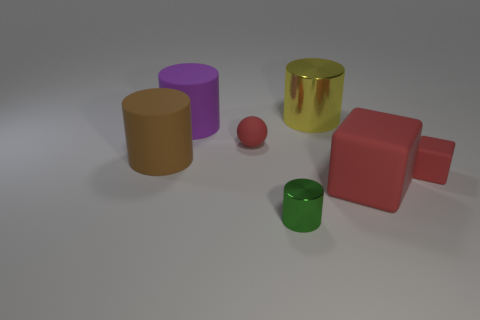Subtract all purple cylinders. How many cylinders are left? 3 Subtract all cylinders. How many objects are left? 3 Add 2 cyan metal balls. How many objects exist? 9 Subtract 1 cylinders. How many cylinders are left? 3 Subtract all green metallic things. Subtract all red things. How many objects are left? 3 Add 6 green things. How many green things are left? 7 Add 2 small spheres. How many small spheres exist? 3 Subtract all brown cylinders. How many cylinders are left? 3 Subtract 0 cyan cubes. How many objects are left? 7 Subtract all cyan cylinders. Subtract all blue spheres. How many cylinders are left? 4 